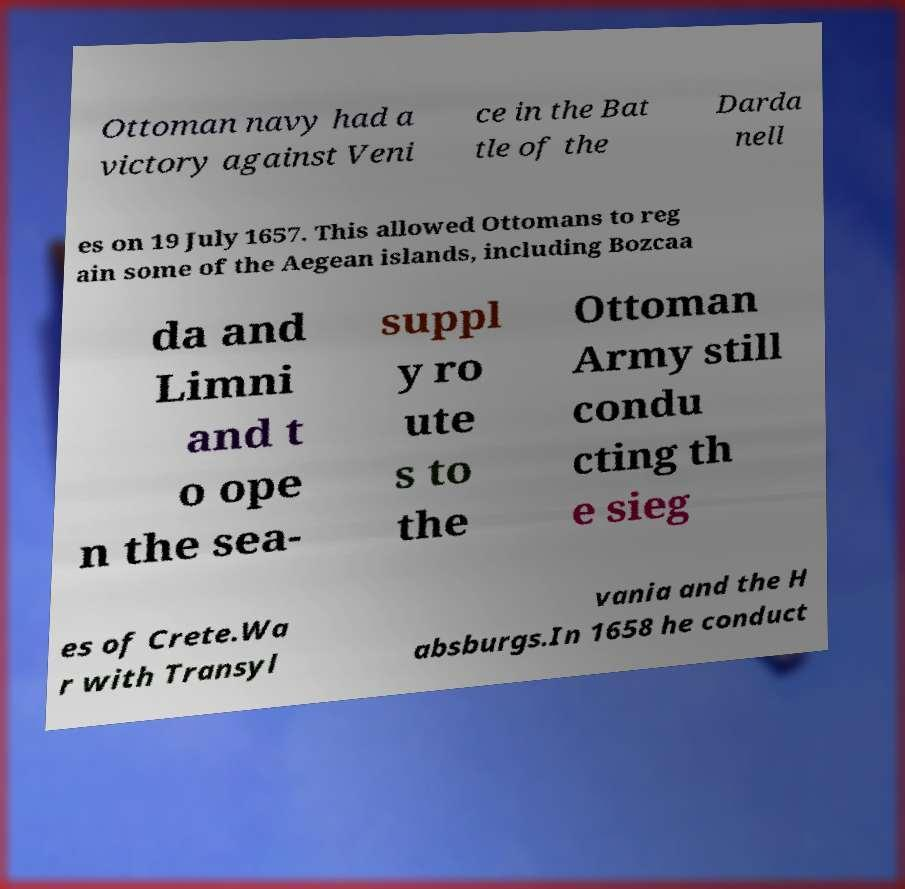Can you accurately transcribe the text from the provided image for me? Ottoman navy had a victory against Veni ce in the Bat tle of the Darda nell es on 19 July 1657. This allowed Ottomans to reg ain some of the Aegean islands, including Bozcaa da and Limni and t o ope n the sea- suppl y ro ute s to the Ottoman Army still condu cting th e sieg es of Crete.Wa r with Transyl vania and the H absburgs.In 1658 he conduct 